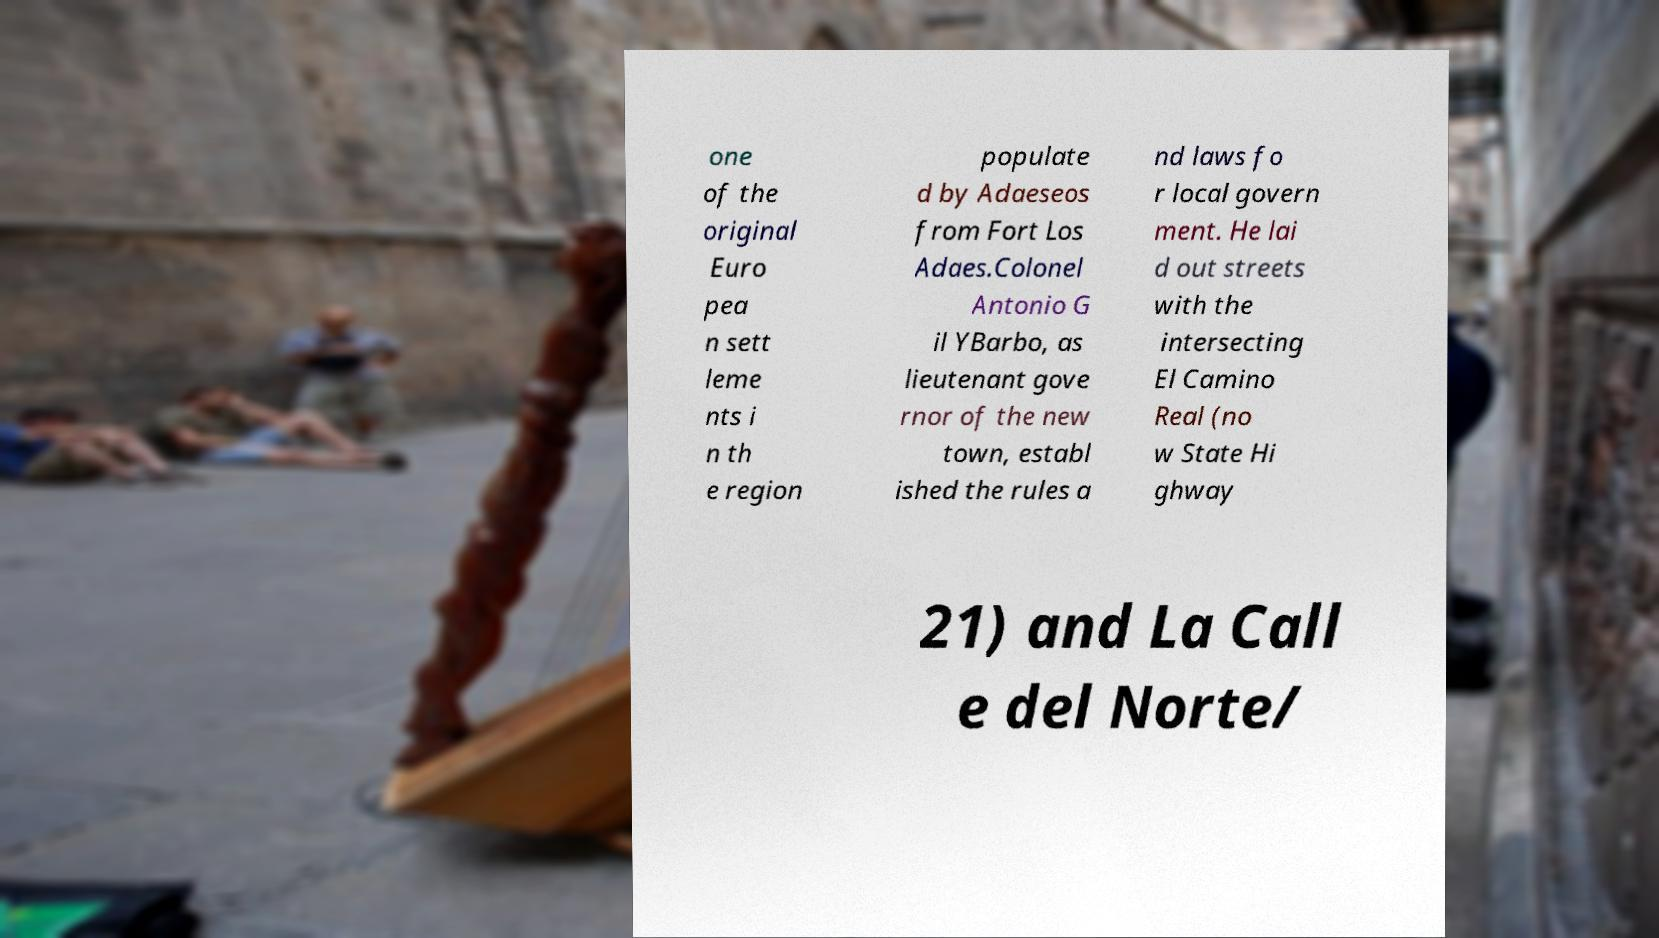Could you extract and type out the text from this image? one of the original Euro pea n sett leme nts i n th e region populate d by Adaeseos from Fort Los Adaes.Colonel Antonio G il YBarbo, as lieutenant gove rnor of the new town, establ ished the rules a nd laws fo r local govern ment. He lai d out streets with the intersecting El Camino Real (no w State Hi ghway 21) and La Call e del Norte/ 